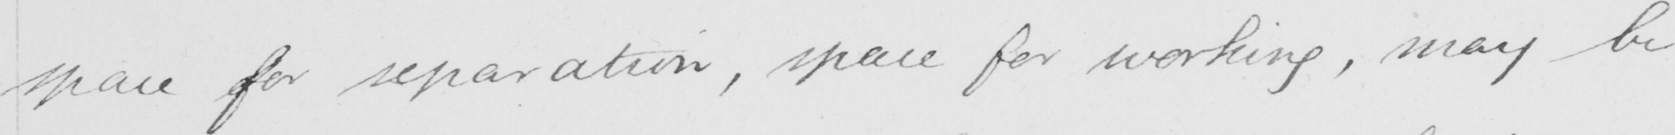Please provide the text content of this handwritten line. space for separation , space for working , may be 